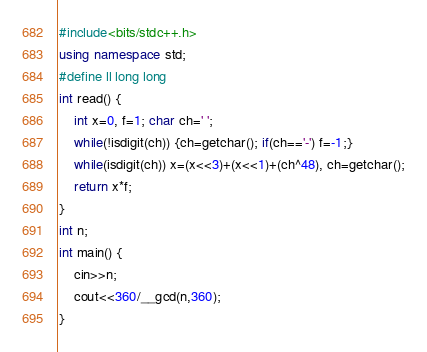<code> <loc_0><loc_0><loc_500><loc_500><_C++_>#include<bits/stdc++.h>
using namespace std;
#define ll long long
int read() {
	int x=0, f=1; char ch=' ';
	while(!isdigit(ch)) {ch=getchar(); if(ch=='-') f=-1;}
	while(isdigit(ch)) x=(x<<3)+(x<<1)+(ch^48), ch=getchar();
	return x*f;
}
int n; 
int main() {
	cin>>n;
	cout<<360/__gcd(n,360);
}
</code> 